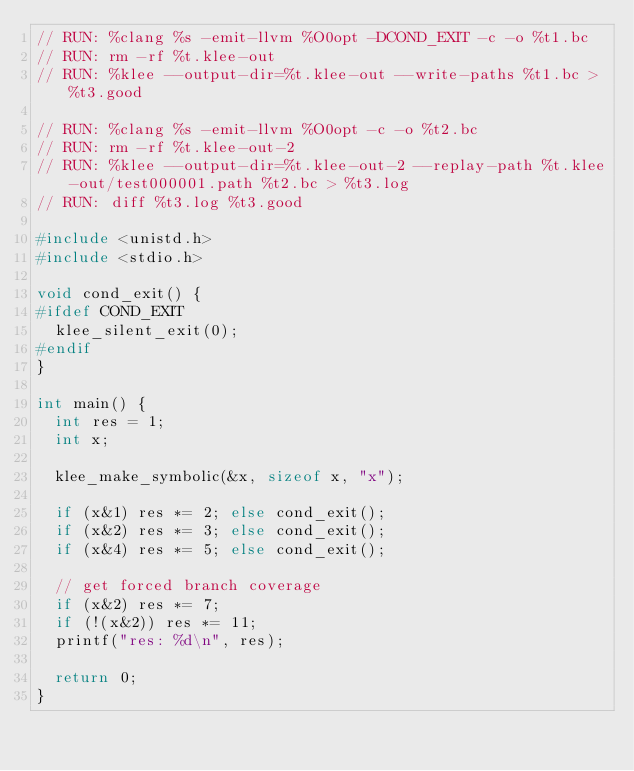<code> <loc_0><loc_0><loc_500><loc_500><_C_>// RUN: %clang %s -emit-llvm %O0opt -DCOND_EXIT -c -o %t1.bc
// RUN: rm -rf %t.klee-out
// RUN: %klee --output-dir=%t.klee-out --write-paths %t1.bc > %t3.good

// RUN: %clang %s -emit-llvm %O0opt -c -o %t2.bc
// RUN: rm -rf %t.klee-out-2
// RUN: %klee --output-dir=%t.klee-out-2 --replay-path %t.klee-out/test000001.path %t2.bc > %t3.log
// RUN: diff %t3.log %t3.good

#include <unistd.h>
#include <stdio.h>

void cond_exit() {
#ifdef COND_EXIT
  klee_silent_exit(0);
#endif
}

int main() {
  int res = 1;
  int x;

  klee_make_symbolic(&x, sizeof x, "x");

  if (x&1) res *= 2; else cond_exit();
  if (x&2) res *= 3; else cond_exit();
  if (x&4) res *= 5; else cond_exit();

  // get forced branch coverage
  if (x&2) res *= 7;
  if (!(x&2)) res *= 11;
  printf("res: %d\n", res);
 
  return 0;
}
</code> 